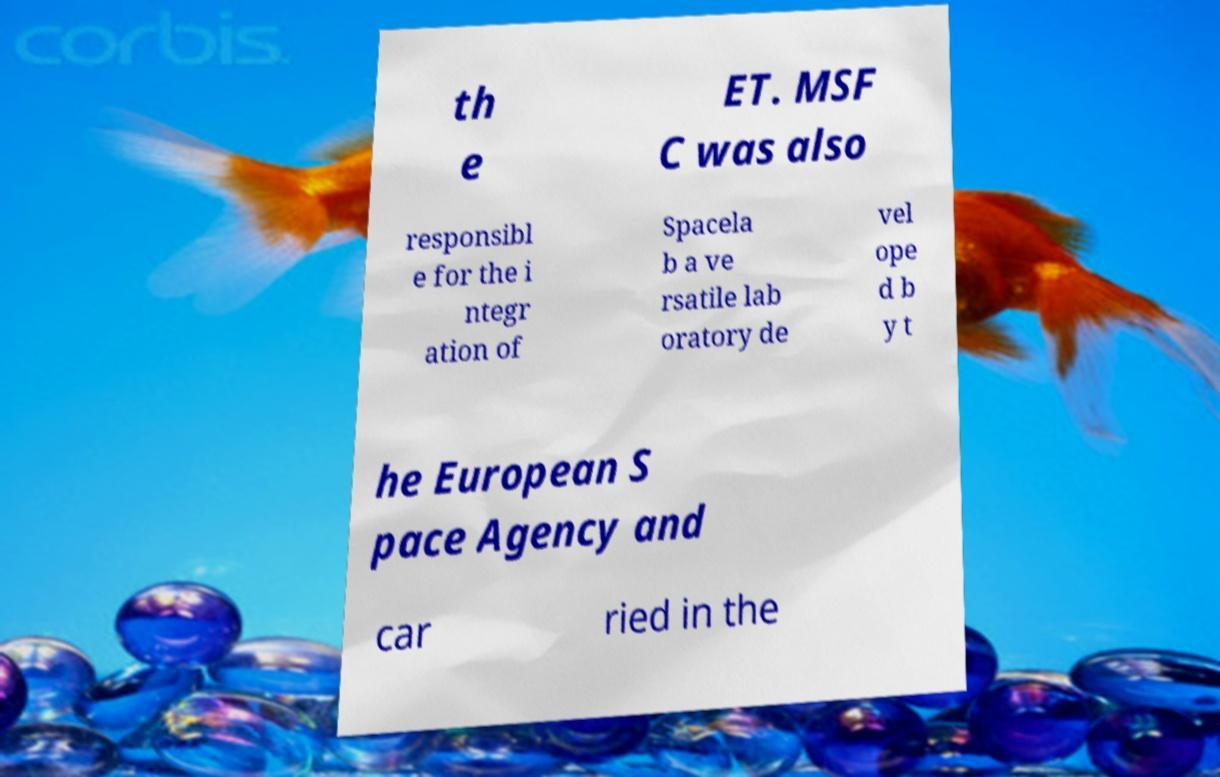For documentation purposes, I need the text within this image transcribed. Could you provide that? th e ET. MSF C was also responsibl e for the i ntegr ation of Spacela b a ve rsatile lab oratory de vel ope d b y t he European S pace Agency and car ried in the 